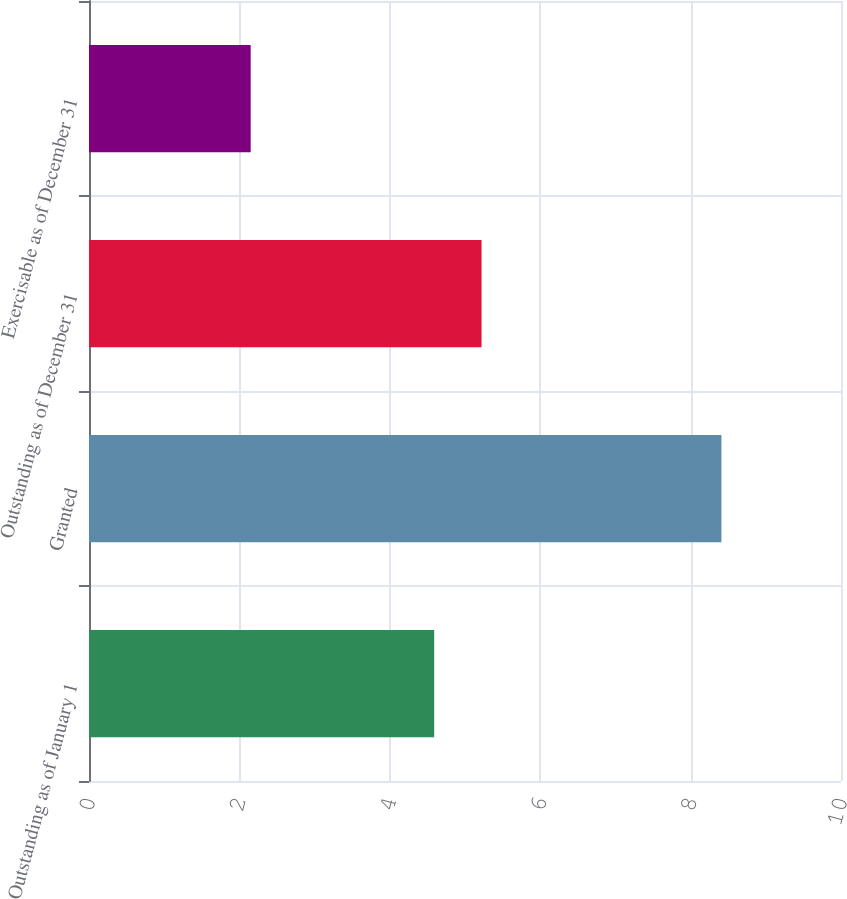Convert chart to OTSL. <chart><loc_0><loc_0><loc_500><loc_500><bar_chart><fcel>Outstanding as of January 1<fcel>Granted<fcel>Outstanding as of December 31<fcel>Exercisable as of December 31<nl><fcel>4.59<fcel>8.41<fcel>5.22<fcel>2.15<nl></chart> 